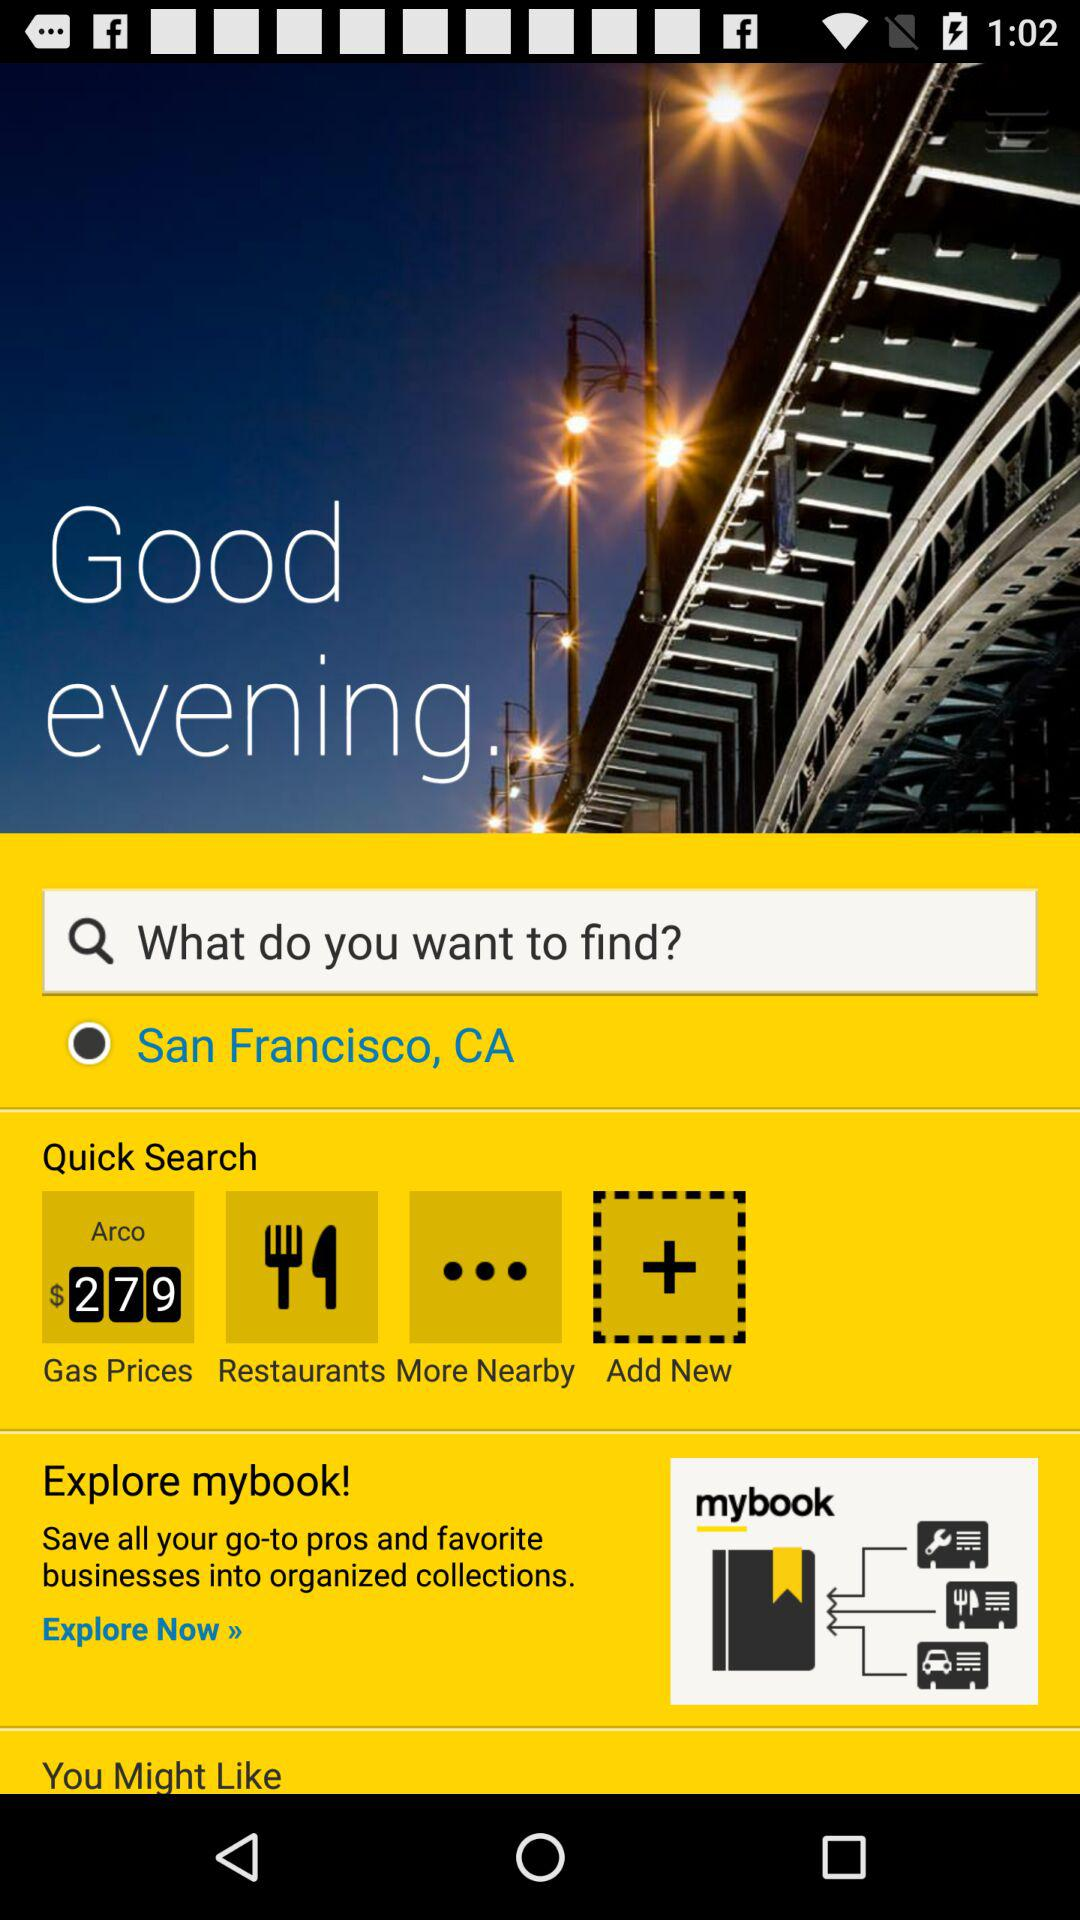What applications do we have to explore? The application is "mybook". 